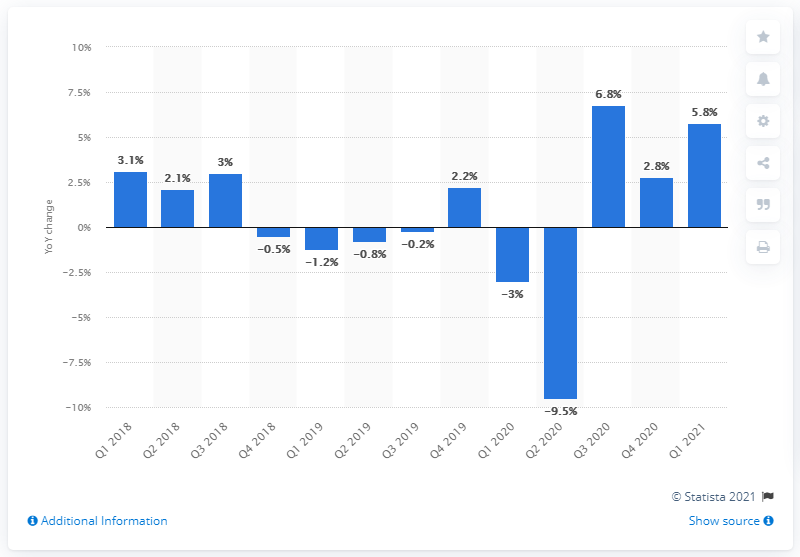Specify some key components in this picture. According to recent estimates, Norway's Gross Domestic Product (GDP) grew by 5.8% in the first quarter of 2021. 